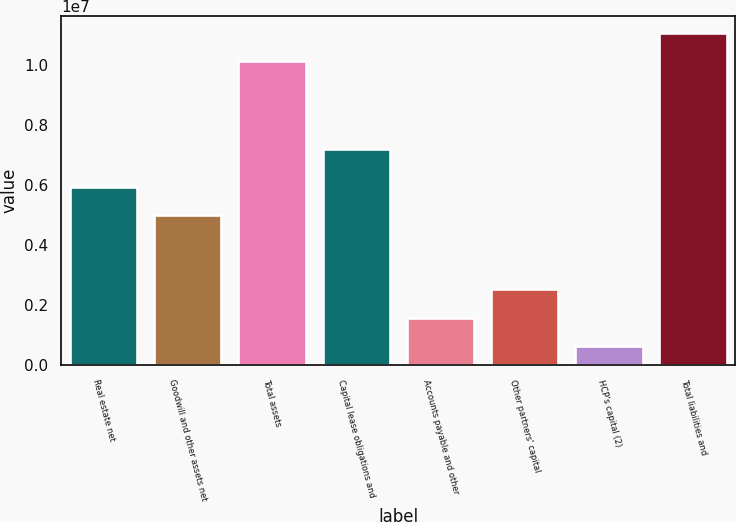Convert chart to OTSL. <chart><loc_0><loc_0><loc_500><loc_500><bar_chart><fcel>Real estate net<fcel>Goodwill and other assets net<fcel>Total assets<fcel>Capital lease obligations and<fcel>Accounts payable and other<fcel>Other partners' capital<fcel>HCP's capital (2)<fcel>Total liabilities and<nl><fcel>5.93584e+06<fcel>4.98631e+06<fcel>1.01209e+07<fcel>7.19794e+06<fcel>1.57516e+06<fcel>2.52468e+06<fcel>625632<fcel>1.10704e+07<nl></chart> 